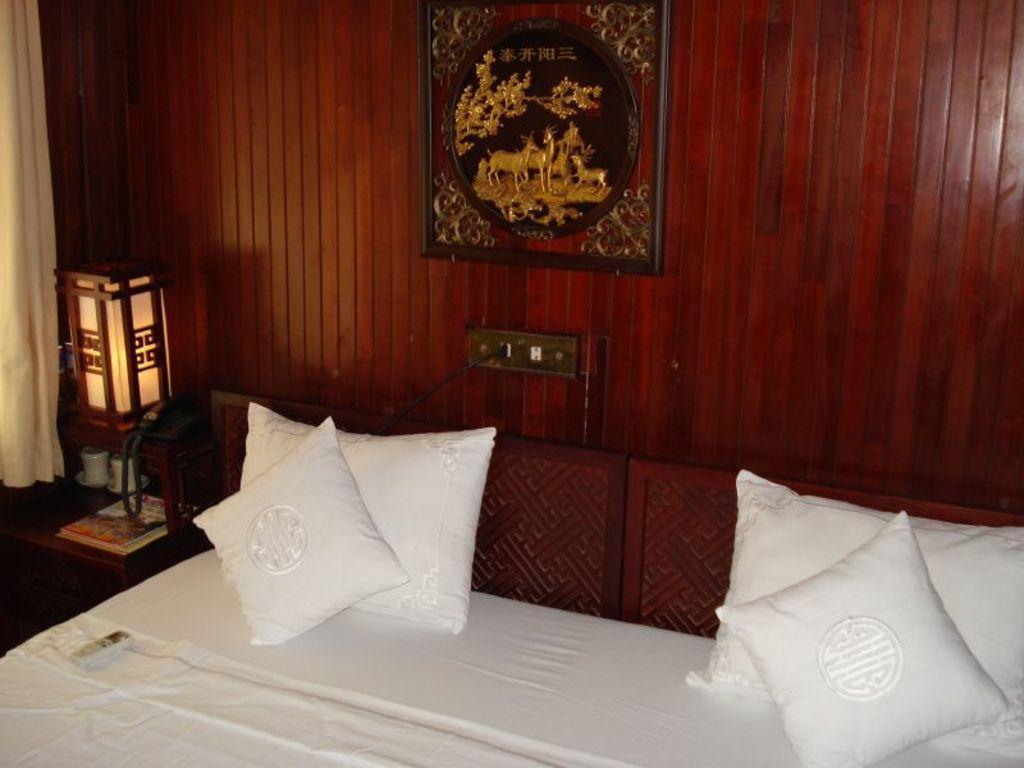How would you summarize this image in a sentence or two? In this image I can see a room with bed and pillows and they are in white color. To the left there is a table. On that there are cups,books,telephone and the lamp. To the side of that there is a curtain. In the back ground there is a switch board and frame attached to the wall. 